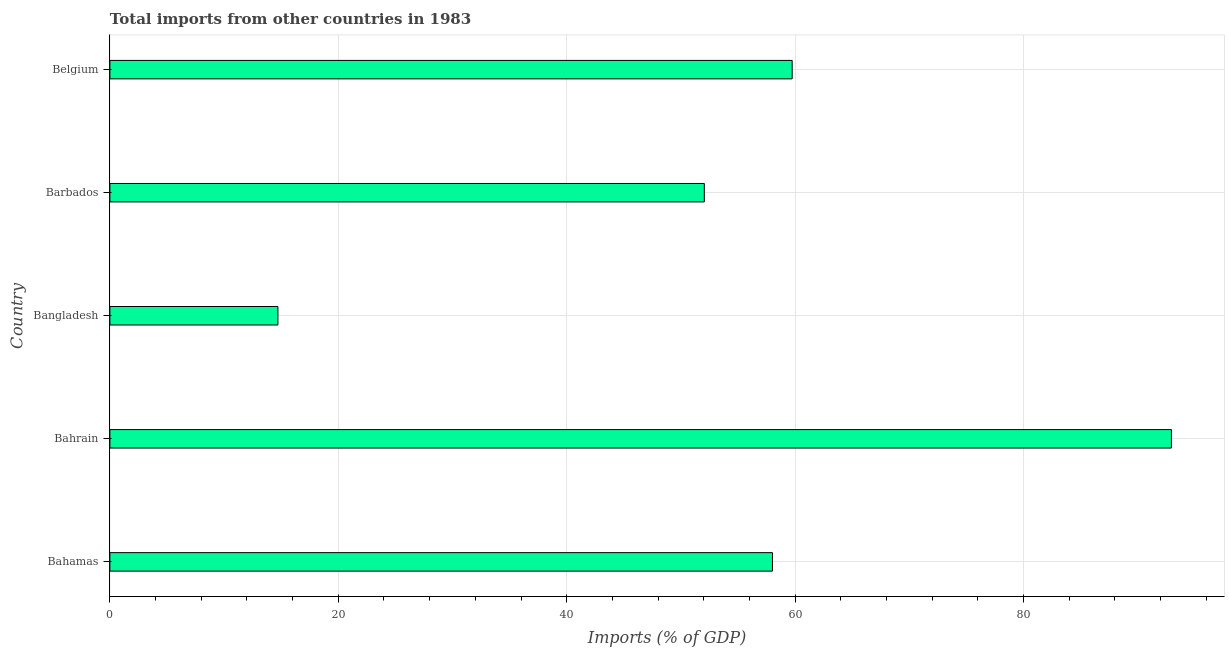Does the graph contain any zero values?
Provide a succinct answer. No. What is the title of the graph?
Ensure brevity in your answer.  Total imports from other countries in 1983. What is the label or title of the X-axis?
Your answer should be very brief. Imports (% of GDP). What is the label or title of the Y-axis?
Offer a very short reply. Country. What is the total imports in Belgium?
Give a very brief answer. 59.74. Across all countries, what is the maximum total imports?
Your answer should be very brief. 92.95. Across all countries, what is the minimum total imports?
Offer a very short reply. 14.71. In which country was the total imports maximum?
Offer a very short reply. Bahrain. In which country was the total imports minimum?
Your answer should be compact. Bangladesh. What is the sum of the total imports?
Your answer should be compact. 277.47. What is the difference between the total imports in Bangladesh and Belgium?
Your answer should be compact. -45.03. What is the average total imports per country?
Offer a terse response. 55.49. What is the median total imports?
Your answer should be compact. 58.02. What is the ratio of the total imports in Bahrain to that in Belgium?
Your answer should be very brief. 1.56. Is the total imports in Bangladesh less than that in Barbados?
Your answer should be compact. Yes. Is the difference between the total imports in Bahrain and Bangladesh greater than the difference between any two countries?
Give a very brief answer. Yes. What is the difference between the highest and the second highest total imports?
Your answer should be very brief. 33.21. What is the difference between the highest and the lowest total imports?
Offer a terse response. 78.24. In how many countries, is the total imports greater than the average total imports taken over all countries?
Ensure brevity in your answer.  3. Are all the bars in the graph horizontal?
Provide a short and direct response. Yes. What is the difference between two consecutive major ticks on the X-axis?
Your answer should be compact. 20. Are the values on the major ticks of X-axis written in scientific E-notation?
Your response must be concise. No. What is the Imports (% of GDP) in Bahamas?
Offer a terse response. 58.02. What is the Imports (% of GDP) in Bahrain?
Your response must be concise. 92.95. What is the Imports (% of GDP) of Bangladesh?
Make the answer very short. 14.71. What is the Imports (% of GDP) of Barbados?
Your response must be concise. 52.05. What is the Imports (% of GDP) of Belgium?
Keep it short and to the point. 59.74. What is the difference between the Imports (% of GDP) in Bahamas and Bahrain?
Your response must be concise. -34.93. What is the difference between the Imports (% of GDP) in Bahamas and Bangladesh?
Provide a succinct answer. 43.3. What is the difference between the Imports (% of GDP) in Bahamas and Barbados?
Provide a succinct answer. 5.96. What is the difference between the Imports (% of GDP) in Bahamas and Belgium?
Give a very brief answer. -1.73. What is the difference between the Imports (% of GDP) in Bahrain and Bangladesh?
Your answer should be compact. 78.24. What is the difference between the Imports (% of GDP) in Bahrain and Barbados?
Ensure brevity in your answer.  40.9. What is the difference between the Imports (% of GDP) in Bahrain and Belgium?
Your response must be concise. 33.21. What is the difference between the Imports (% of GDP) in Bangladesh and Barbados?
Your response must be concise. -37.34. What is the difference between the Imports (% of GDP) in Bangladesh and Belgium?
Provide a succinct answer. -45.03. What is the difference between the Imports (% of GDP) in Barbados and Belgium?
Your answer should be very brief. -7.69. What is the ratio of the Imports (% of GDP) in Bahamas to that in Bahrain?
Offer a very short reply. 0.62. What is the ratio of the Imports (% of GDP) in Bahamas to that in Bangladesh?
Give a very brief answer. 3.94. What is the ratio of the Imports (% of GDP) in Bahamas to that in Barbados?
Offer a terse response. 1.11. What is the ratio of the Imports (% of GDP) in Bahrain to that in Bangladesh?
Provide a short and direct response. 6.32. What is the ratio of the Imports (% of GDP) in Bahrain to that in Barbados?
Keep it short and to the point. 1.79. What is the ratio of the Imports (% of GDP) in Bahrain to that in Belgium?
Give a very brief answer. 1.56. What is the ratio of the Imports (% of GDP) in Bangladesh to that in Barbados?
Your response must be concise. 0.28. What is the ratio of the Imports (% of GDP) in Bangladesh to that in Belgium?
Your response must be concise. 0.25. What is the ratio of the Imports (% of GDP) in Barbados to that in Belgium?
Your response must be concise. 0.87. 